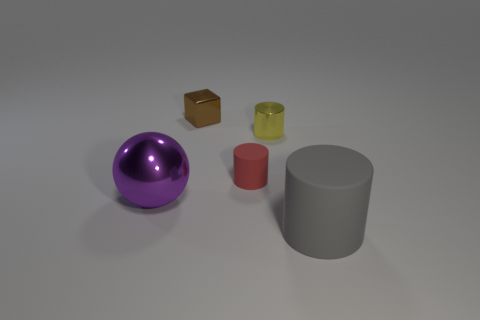What is the cylinder in front of the large object behind the gray matte cylinder made of?
Ensure brevity in your answer.  Rubber. What number of objects are either shiny cylinders or small things behind the small yellow shiny cylinder?
Keep it short and to the point. 2. The gray thing that is the same material as the small red object is what size?
Your answer should be compact. Large. How many blue things are tiny blocks or big matte objects?
Offer a terse response. 0. Is there anything else that has the same material as the big ball?
Your answer should be compact. Yes. There is a large thing that is in front of the purple sphere; is it the same shape as the small thing that is to the left of the tiny red rubber cylinder?
Your answer should be compact. No. How many yellow metal objects are there?
Offer a very short reply. 1. The other thing that is the same material as the gray thing is what shape?
Your answer should be very brief. Cylinder. Is there any other thing that has the same color as the cube?
Your answer should be very brief. No. There is a large cylinder; does it have the same color as the rubber object that is behind the big metallic ball?
Your answer should be compact. No. 